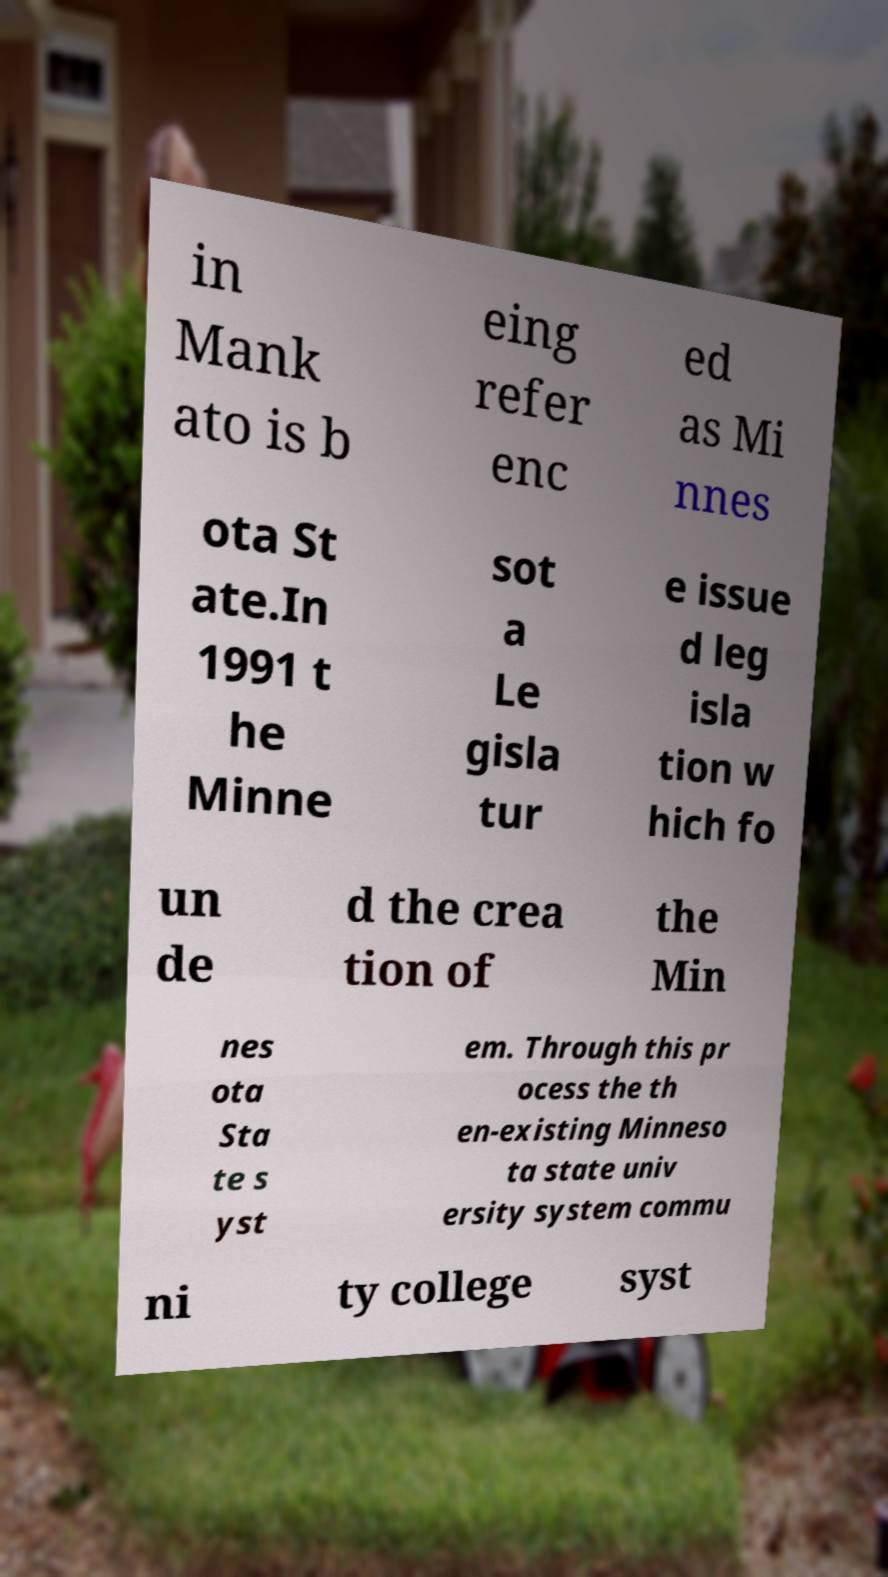Can you read and provide the text displayed in the image?This photo seems to have some interesting text. Can you extract and type it out for me? in Mank ato is b eing refer enc ed as Mi nnes ota St ate.In 1991 t he Minne sot a Le gisla tur e issue d leg isla tion w hich fo un de d the crea tion of the Min nes ota Sta te s yst em. Through this pr ocess the th en-existing Minneso ta state univ ersity system commu ni ty college syst 